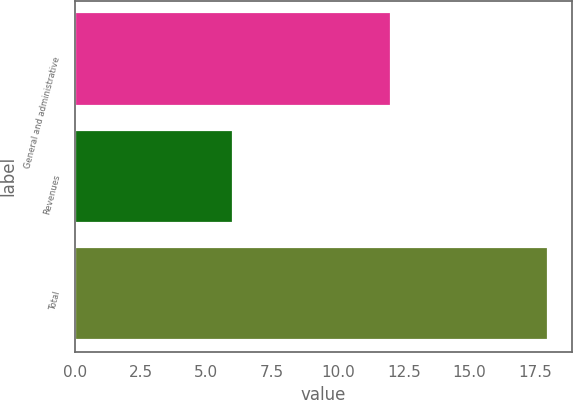<chart> <loc_0><loc_0><loc_500><loc_500><bar_chart><fcel>General and administrative<fcel>Revenues<fcel>Total<nl><fcel>12<fcel>6<fcel>18<nl></chart> 